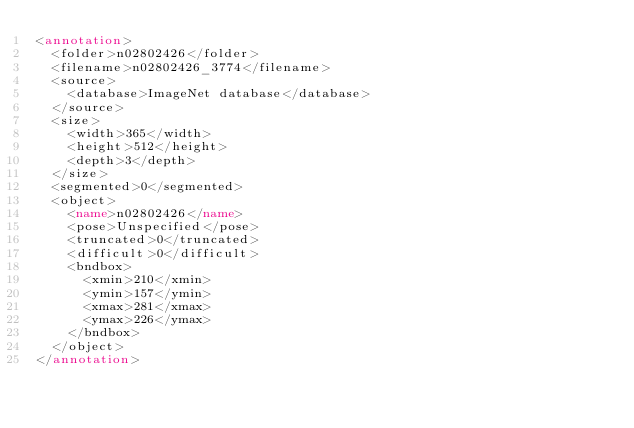<code> <loc_0><loc_0><loc_500><loc_500><_XML_><annotation>
	<folder>n02802426</folder>
	<filename>n02802426_3774</filename>
	<source>
		<database>ImageNet database</database>
	</source>
	<size>
		<width>365</width>
		<height>512</height>
		<depth>3</depth>
	</size>
	<segmented>0</segmented>
	<object>
		<name>n02802426</name>
		<pose>Unspecified</pose>
		<truncated>0</truncated>
		<difficult>0</difficult>
		<bndbox>
			<xmin>210</xmin>
			<ymin>157</ymin>
			<xmax>281</xmax>
			<ymax>226</ymax>
		</bndbox>
	</object>
</annotation></code> 